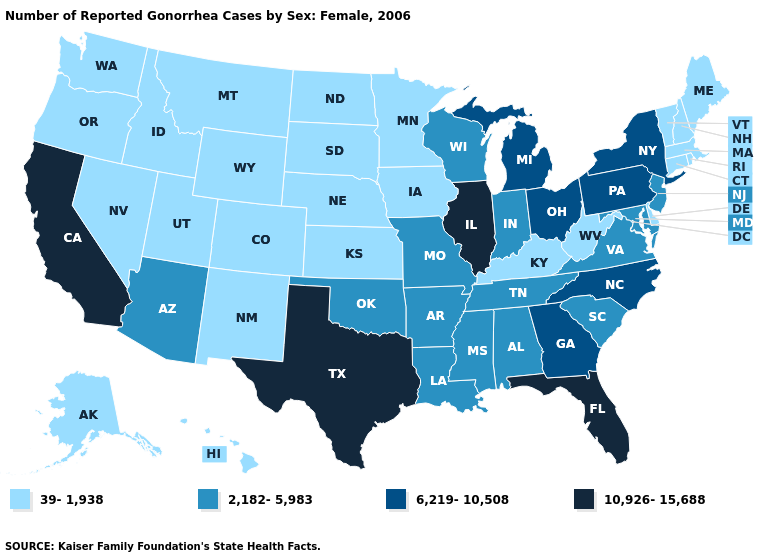Does the first symbol in the legend represent the smallest category?
Be succinct. Yes. What is the lowest value in the USA?
Give a very brief answer. 39-1,938. Name the states that have a value in the range 39-1,938?
Quick response, please. Alaska, Colorado, Connecticut, Delaware, Hawaii, Idaho, Iowa, Kansas, Kentucky, Maine, Massachusetts, Minnesota, Montana, Nebraska, Nevada, New Hampshire, New Mexico, North Dakota, Oregon, Rhode Island, South Dakota, Utah, Vermont, Washington, West Virginia, Wyoming. Does Vermont have a lower value than Tennessee?
Keep it brief. Yes. Does the first symbol in the legend represent the smallest category?
Be succinct. Yes. Which states hav the highest value in the South?
Short answer required. Florida, Texas. Does Florida have the highest value in the USA?
Be succinct. Yes. Does Washington have the same value as Florida?
Give a very brief answer. No. What is the lowest value in the West?
Be succinct. 39-1,938. What is the highest value in the USA?
Concise answer only. 10,926-15,688. Does Mississippi have the lowest value in the USA?
Short answer required. No. Among the states that border South Carolina , which have the lowest value?
Give a very brief answer. Georgia, North Carolina. Among the states that border Nevada , does Arizona have the lowest value?
Short answer required. No. 